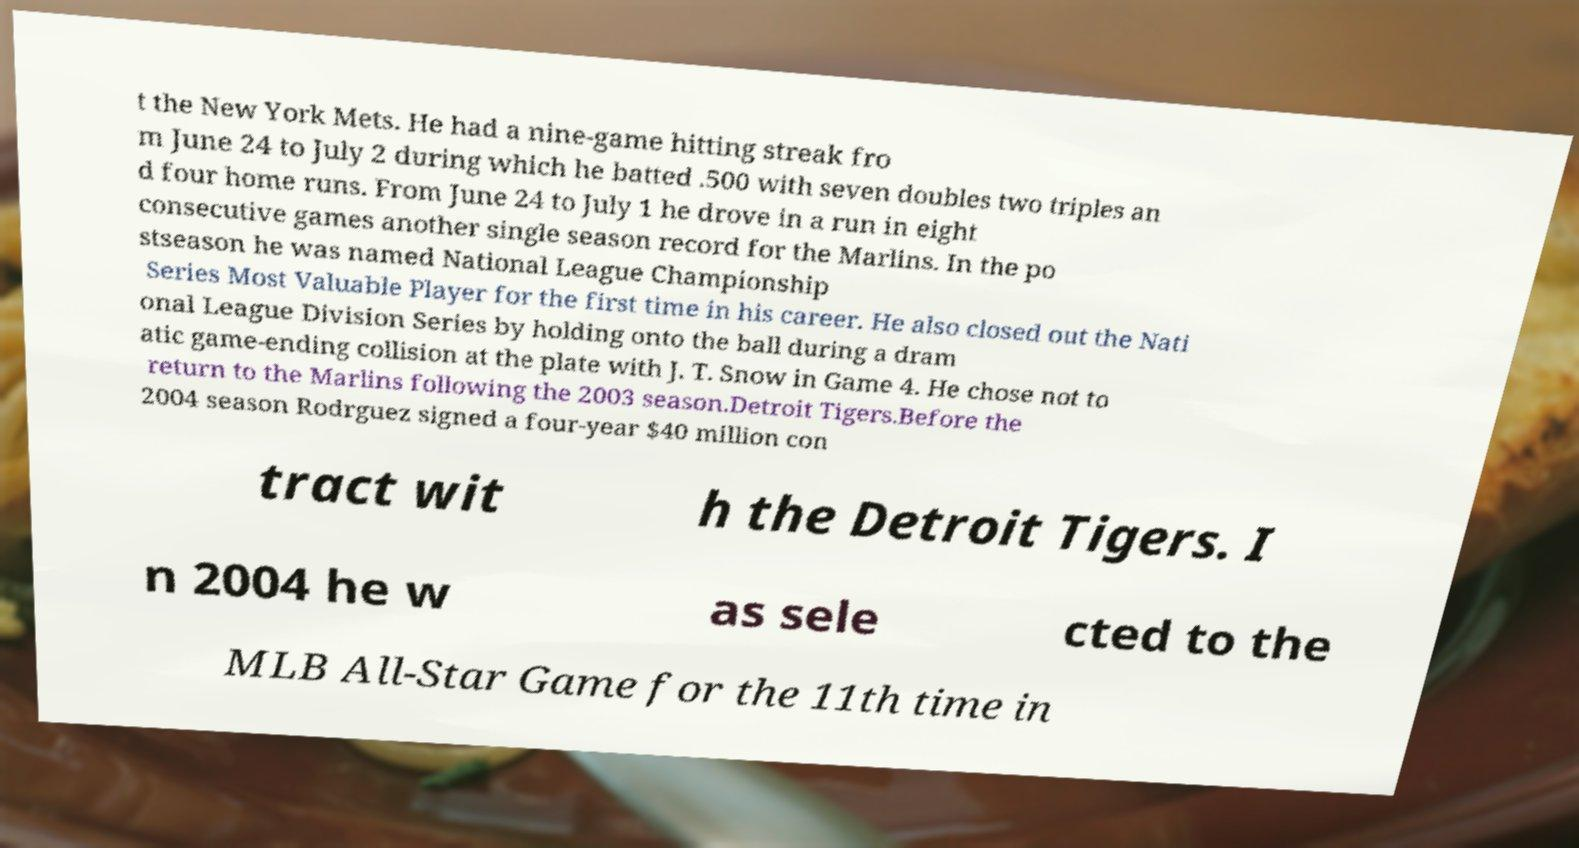Could you extract and type out the text from this image? t the New York Mets. He had a nine-game hitting streak fro m June 24 to July 2 during which he batted .500 with seven doubles two triples an d four home runs. From June 24 to July 1 he drove in a run in eight consecutive games another single season record for the Marlins. In the po stseason he was named National League Championship Series Most Valuable Player for the first time in his career. He also closed out the Nati onal League Division Series by holding onto the ball during a dram atic game-ending collision at the plate with J. T. Snow in Game 4. He chose not to return to the Marlins following the 2003 season.Detroit Tigers.Before the 2004 season Rodrguez signed a four-year $40 million con tract wit h the Detroit Tigers. I n 2004 he w as sele cted to the MLB All-Star Game for the 11th time in 